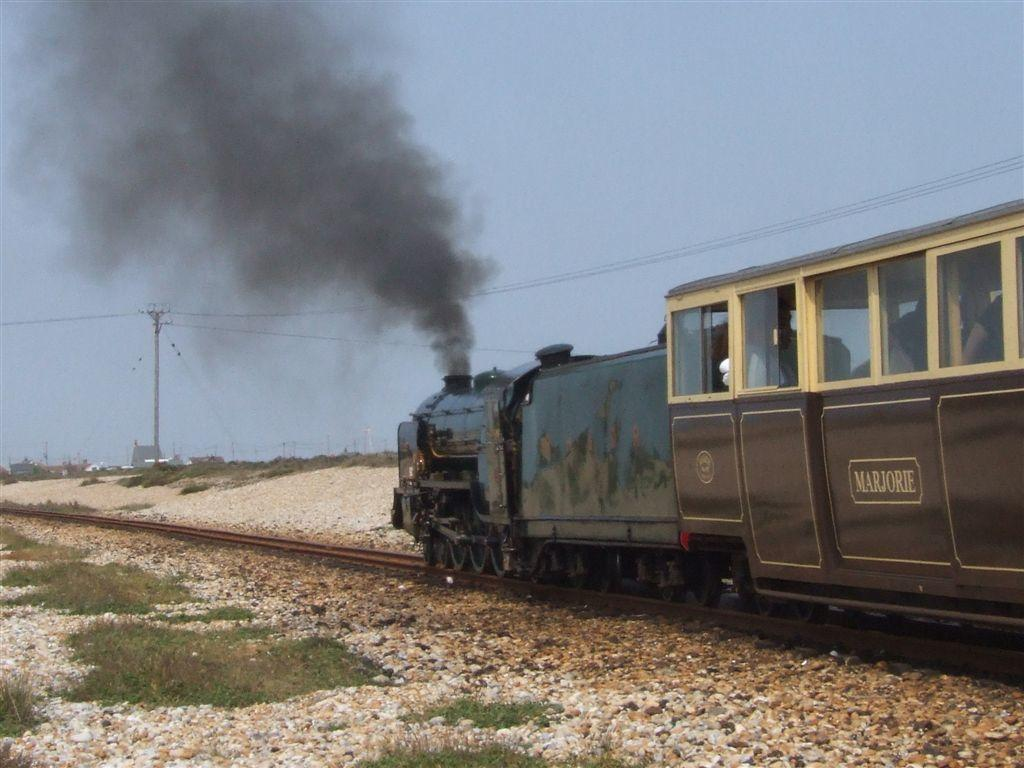What type of transportation infrastructure is visible in the image? There are railway tracks in the image. What is traveling on the railway tracks? There is a train on the railway tracks. What type of vegetation can be seen in the image? There is grass visible in the image. What is being emitted by the train in the image? There is smoke in the image. What else is present in the image besides the railway tracks and train? There are wires visible in the image. What can be seen in the sky in the image? The sky is visible in the image. What type of text or writing is present in the image? There is text or writing present in the image. What type of treatment is being administered to the house in the image? There is no house present in the image, and therefore no treatment can be administered. What type of boundary is visible in the image? There is no boundary visible in the image. 